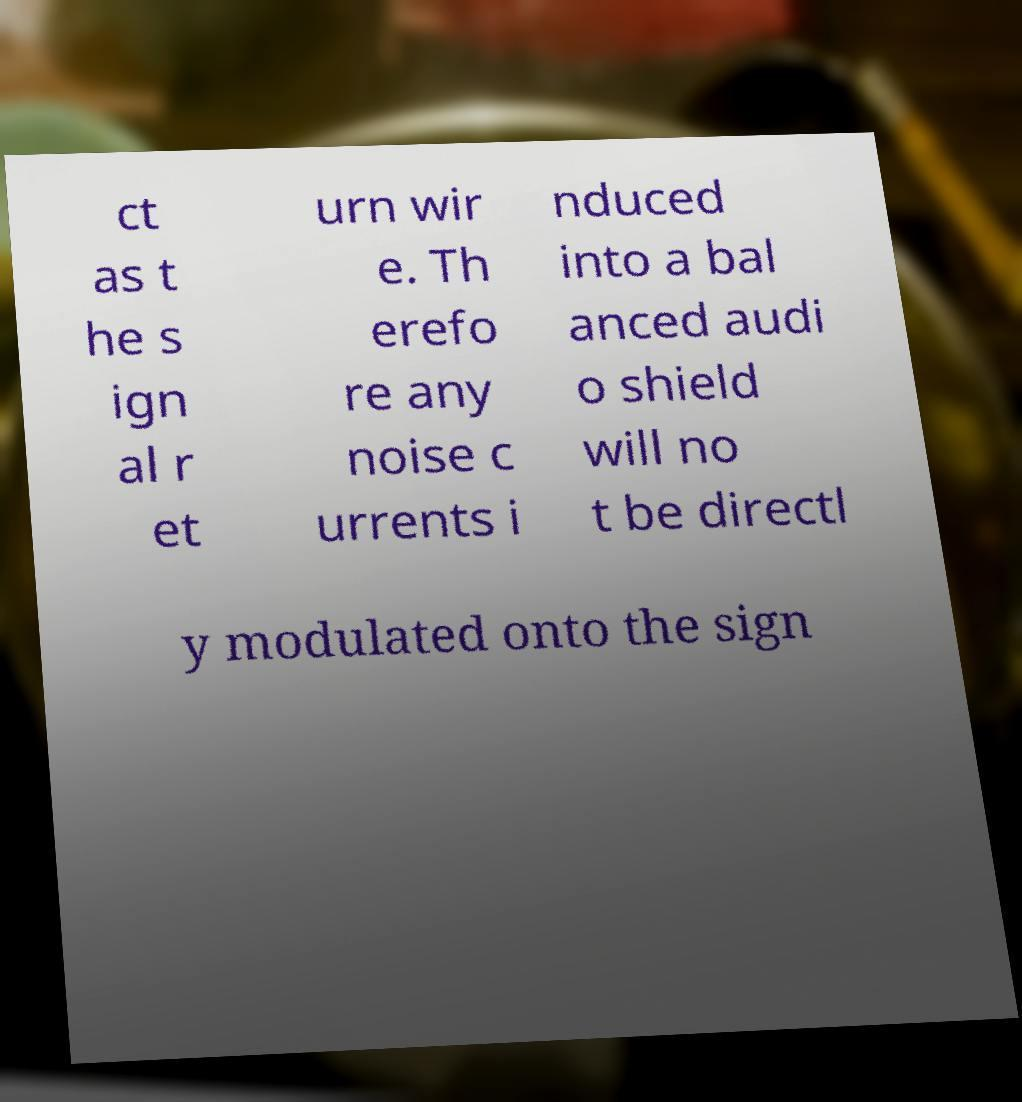Can you read and provide the text displayed in the image?This photo seems to have some interesting text. Can you extract and type it out for me? ct as t he s ign al r et urn wir e. Th erefo re any noise c urrents i nduced into a bal anced audi o shield will no t be directl y modulated onto the sign 